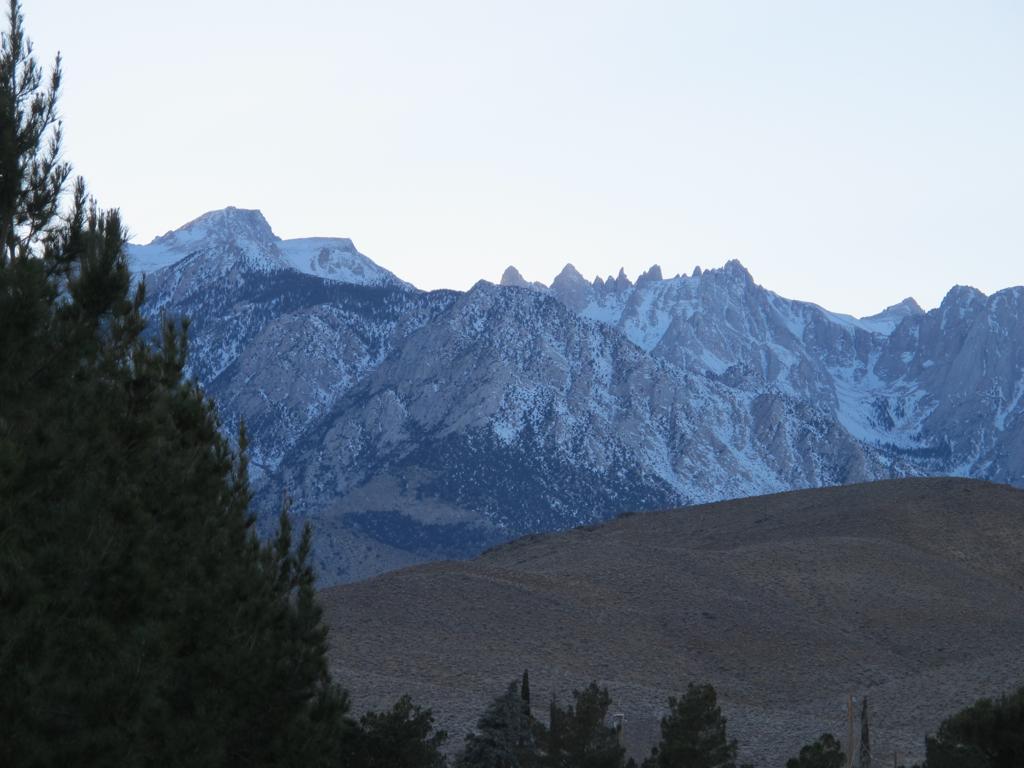How would you summarize this image in a sentence or two? In this image I can see at the bottom there are trees, in the middle there are hills with the snow. At the top there is the sky. 